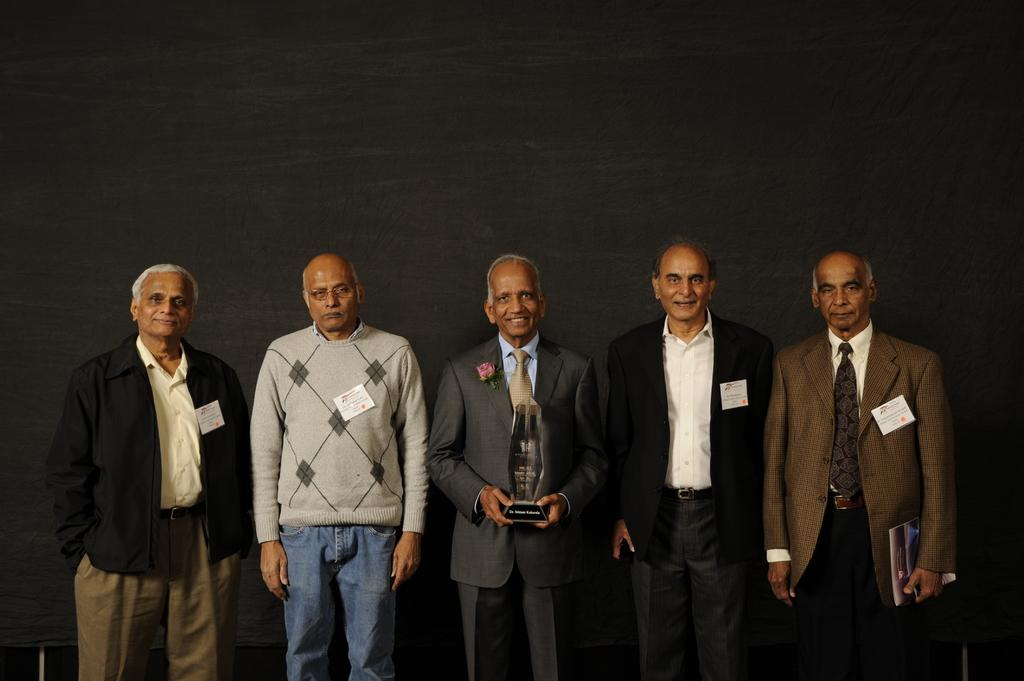What is the main subject of the image? The main subject of the image is a group of people. How are the people dressed in the image? The people are wearing different color dresses in the image. What are two people doing in the image? Two people are holding objects in the image. What color is the background of the image? The background of the image is black. What type of spade is being used by the person in the image? There is no spade present in the image. Can you tell me what flavor of popcorn the people are eating in the image? There is no popcorn present in the image. 